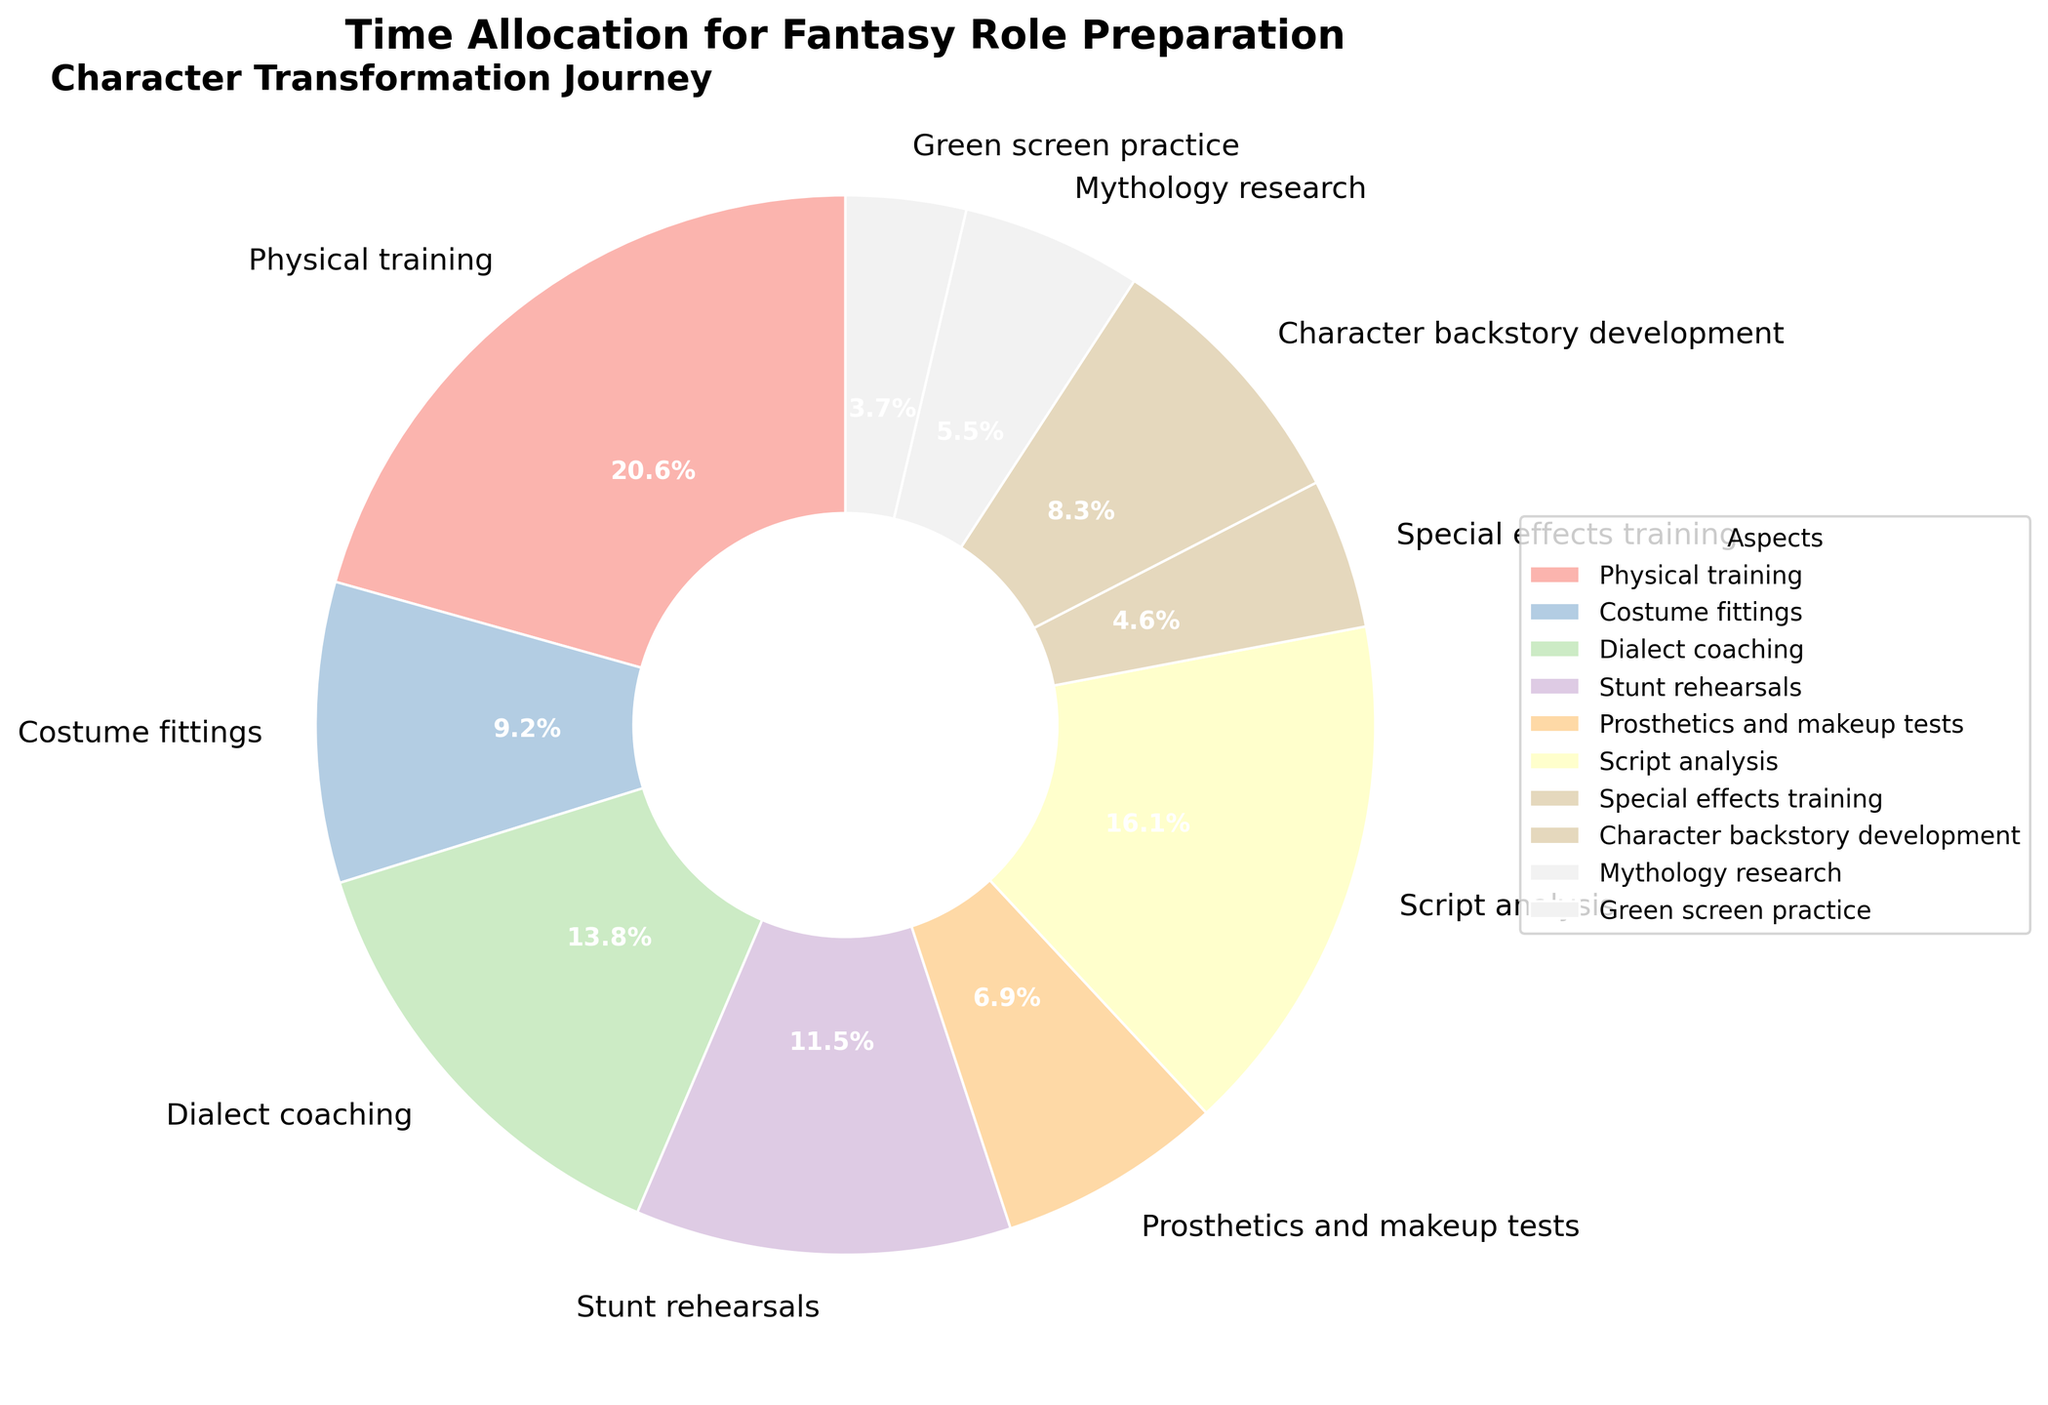What percentage of time is spent on script analysis? Check the pie chart's legend or the percentage on the slice labeled "Script analysis". The slice shows '17.5%'.
Answer: 17.5% Which aspect of character preparation takes the least amount of time? Look for the smallest slice in the pie chart and check its label. "Green screen practice" has the smallest portion.
Answer: Green screen practice How many more hours are spent on physical training compared to stunt rehearsals? Find the slices for "Physical training" and "Stunt rehearsals". Physical training is 45 hours, and stunt rehearsals are 25 hours. The difference is 45 - 25 = 20 hours.
Answer: 20 hours Which aspect takes more time: mythology research or character backstory development? Compare the slices for "Mythology research" and "Character backstory development". The pie chart shows "Character backstory development" has a larger slice.
Answer: Character backstory development What is the combined percentage of time spent on costume fittings and prosthetics and makeup tests? Add the percentage values of the slices for "Costume fittings" and "Prosthetics and makeup tests". Costume fittings are 10%, and prosthetics and makeup tests are 7.5%. The total is 10% + 7.5% = 17.5%.
Answer: 17.5% What visual title is given to the pie chart? Look at the top of the pie chart where the title is usually placed. The title reads "Time Allocation for Fantasy Role Preparation".
Answer: Time Allocation for Fantasy Role Preparation Is more time allocated to dialect coaching or special effects training? Compare the slices for "Dialect coaching" and "Special effects training". Since "Dialect coaching" has a larger slice than "Special effects training", more time is allocated to dialect coaching.
Answer: Dialect coaching How does the width of the slices affect the readability of the pie chart? Analyze the visual effect of having wider slices for better distinction. The width helps in clearly separating different aspects, making it easier to identify each segment quickly.
Answer: It improves readability 